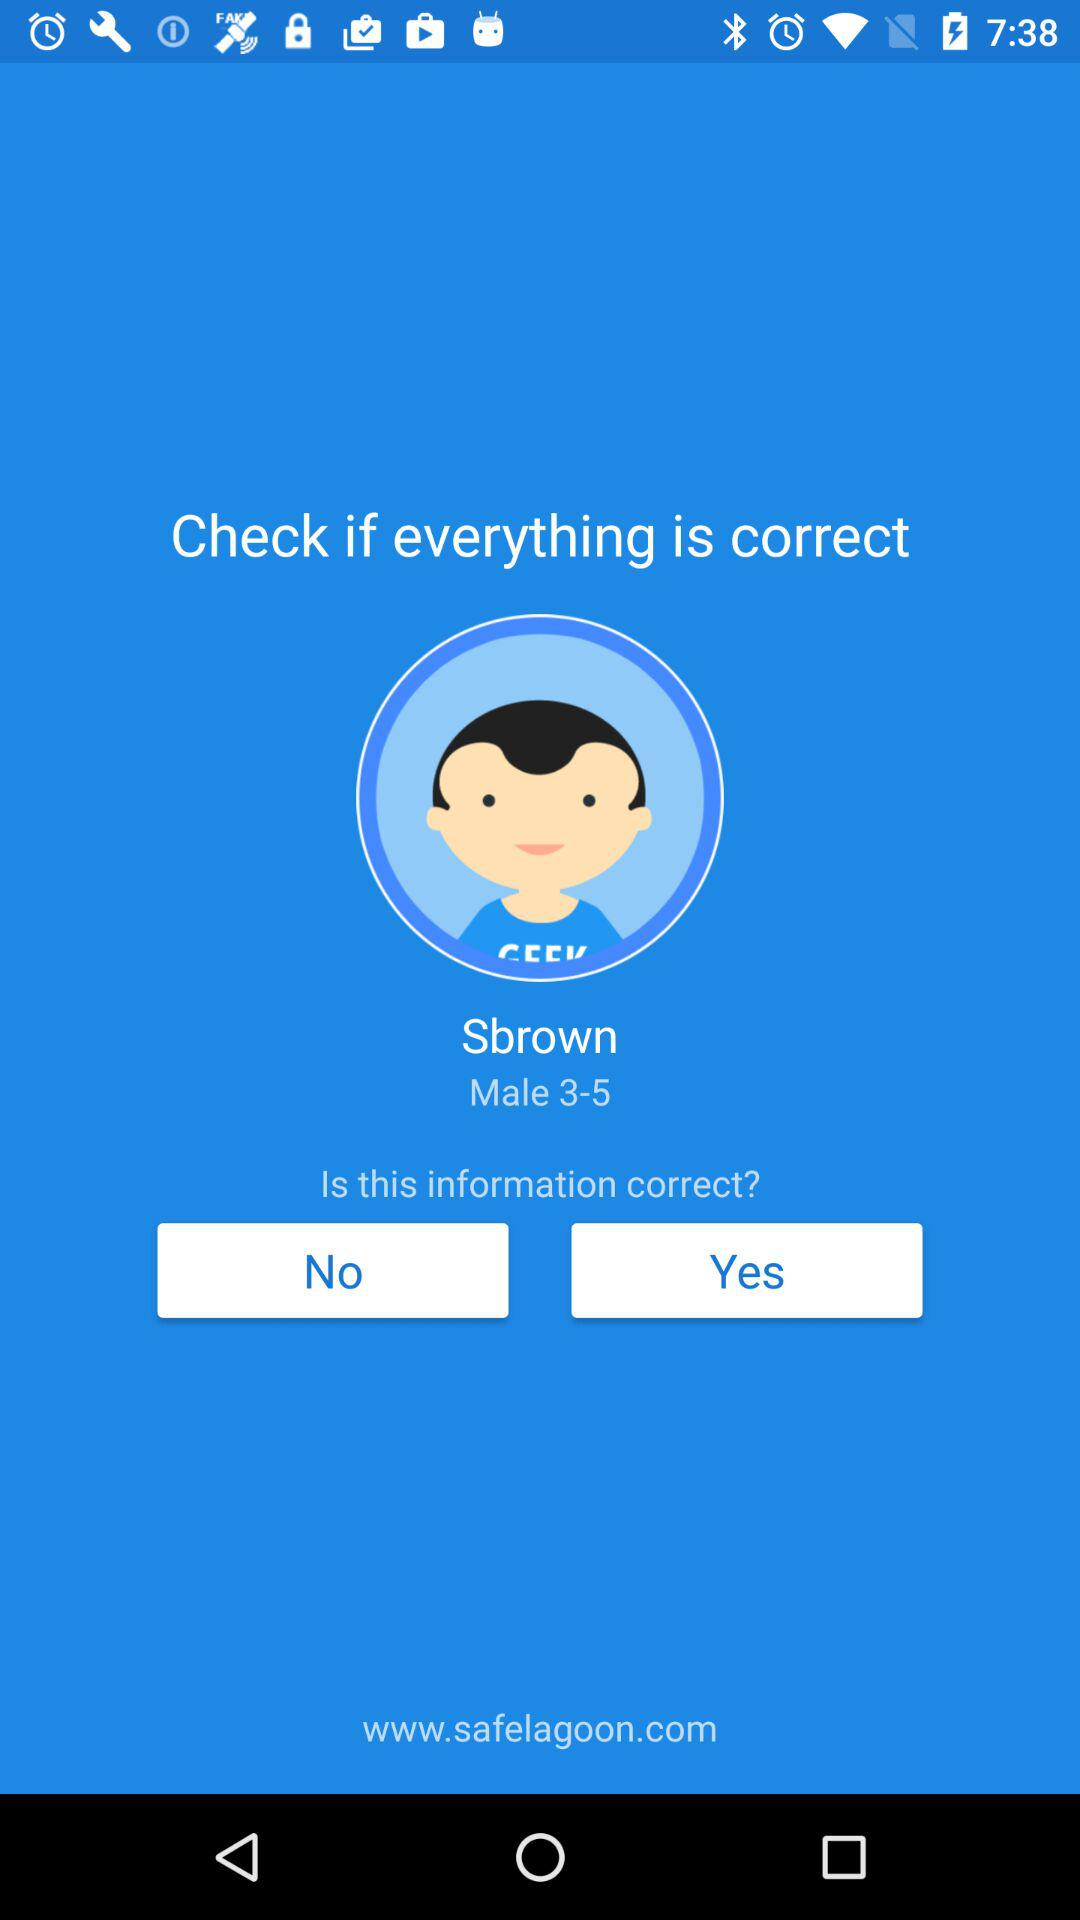What is the given profile name? The given profile name is Sbrown. 